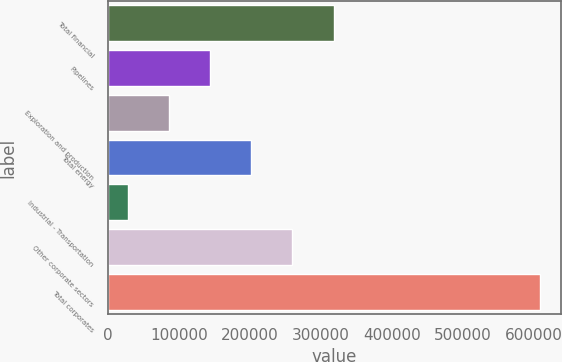Convert chart. <chart><loc_0><loc_0><loc_500><loc_500><bar_chart><fcel>Total financial<fcel>Pipelines<fcel>Exploration and production<fcel>Total energy<fcel>Industrial - Transportation<fcel>Other corporate sectors<fcel>Total corporates<nl><fcel>317778<fcel>143828<fcel>85845.2<fcel>201812<fcel>27862<fcel>259795<fcel>607694<nl></chart> 